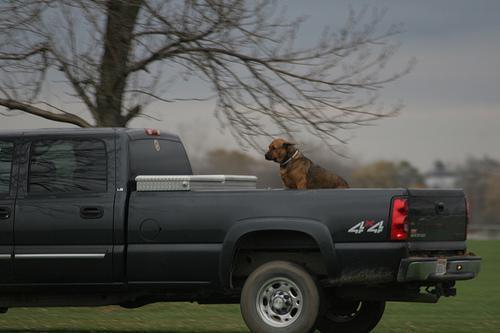How many wheels can be seen?
Give a very brief answer. 2. 